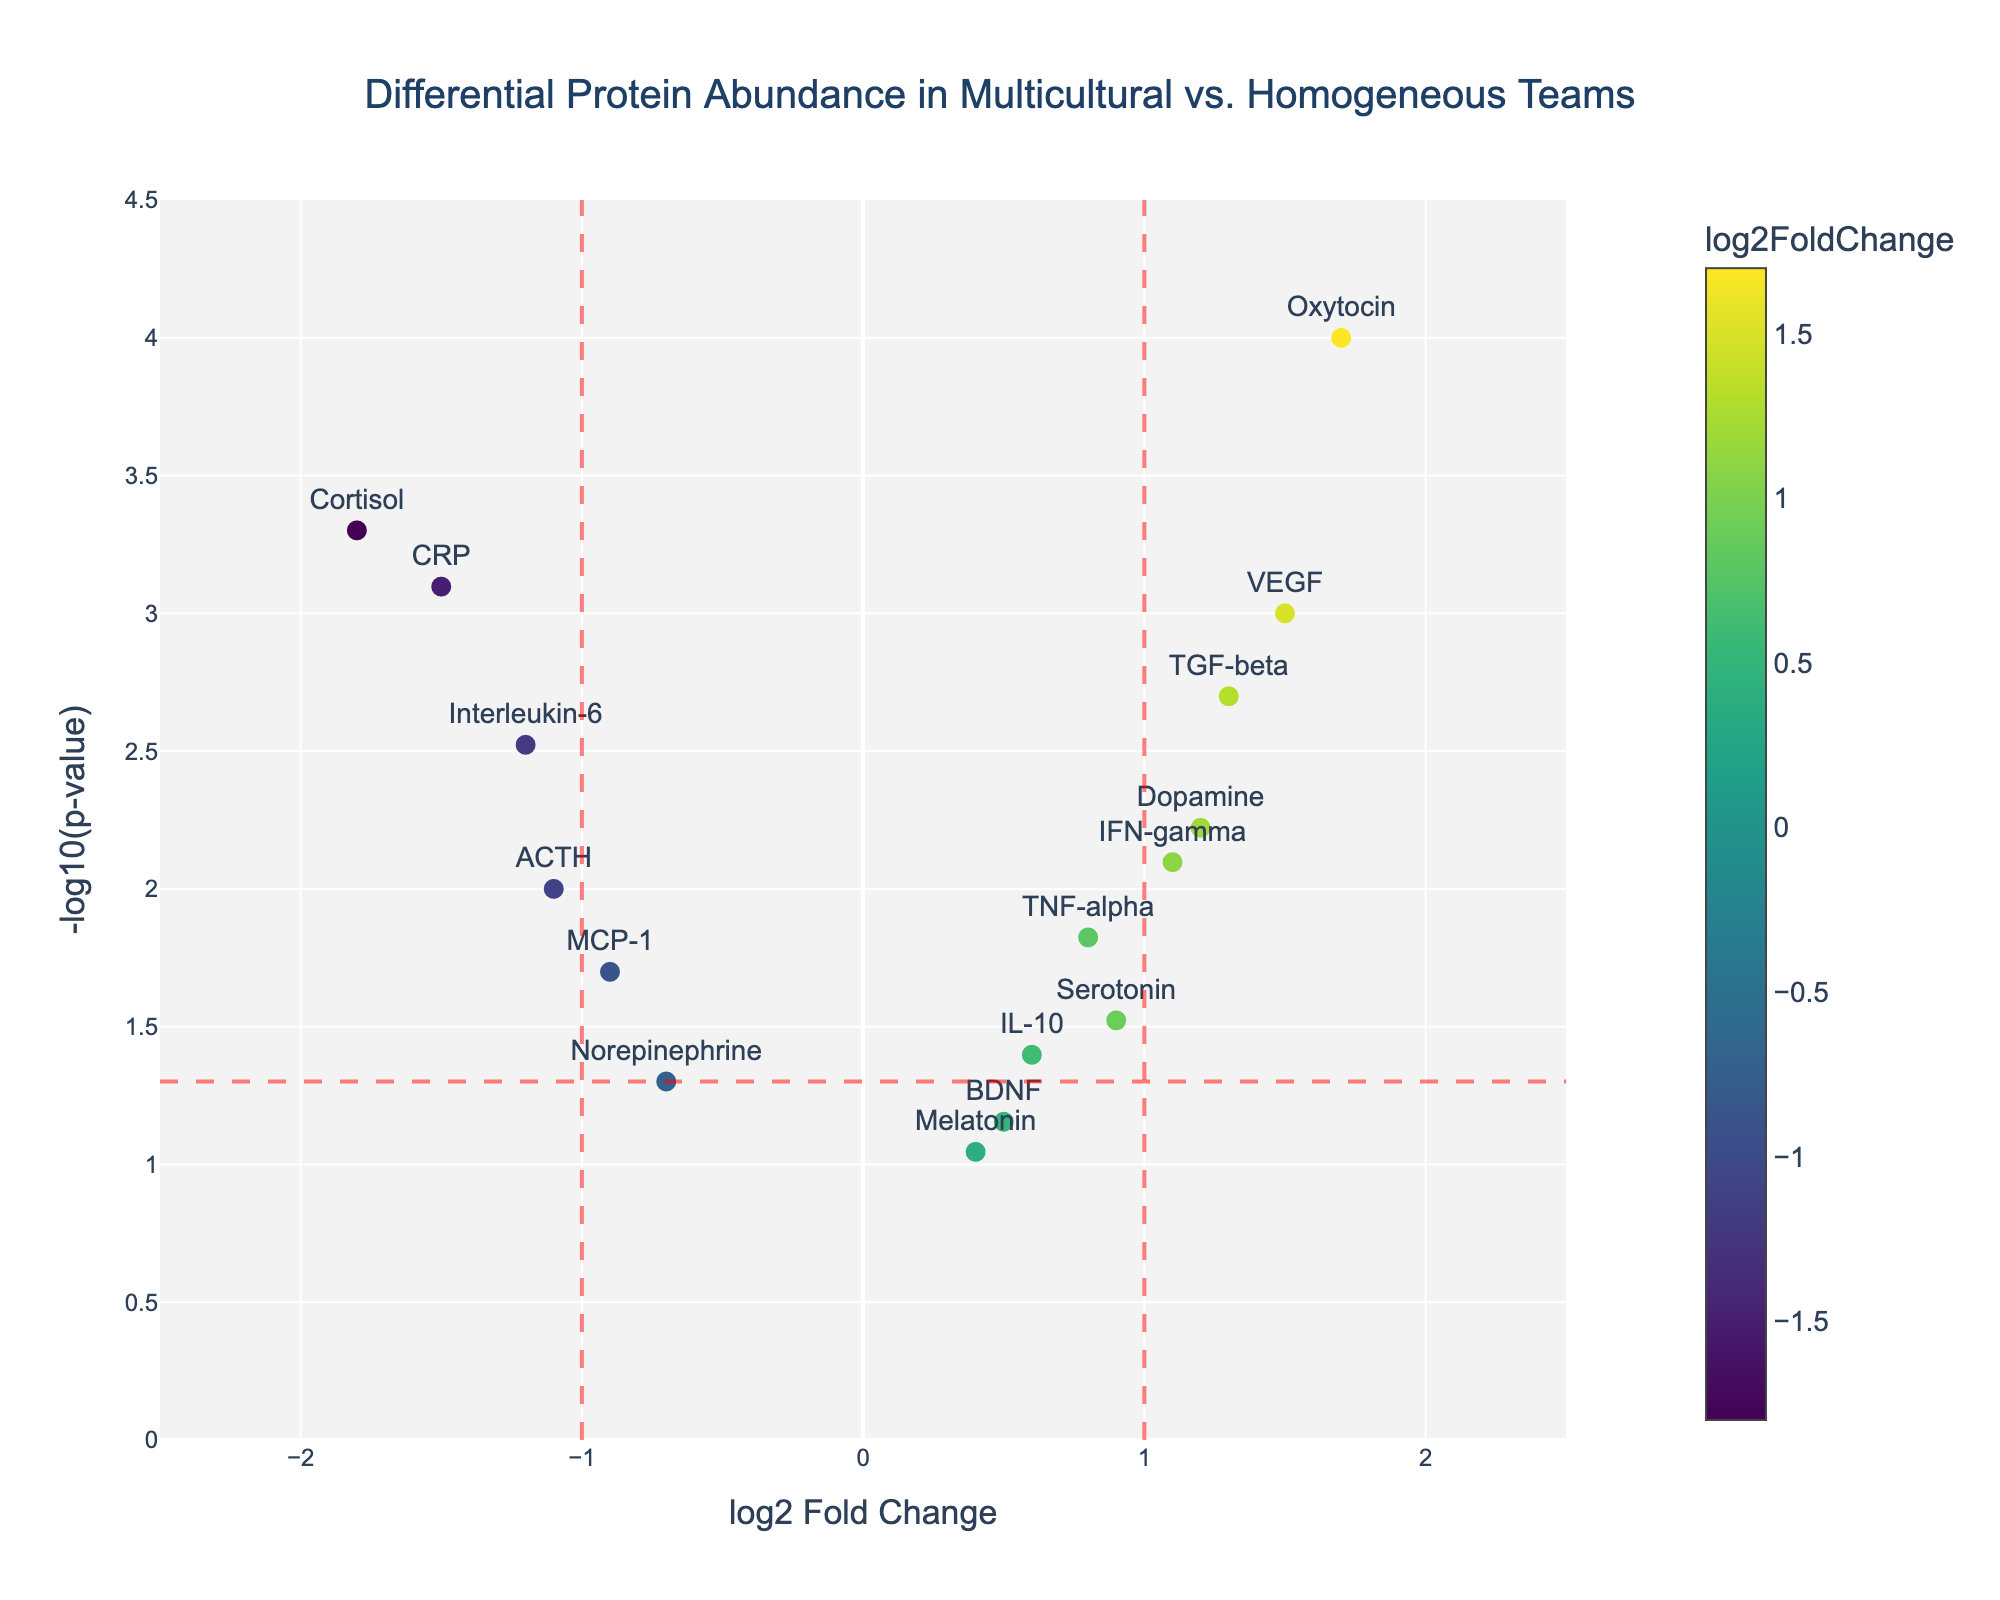What's the title of the figure? The title of the figure is usually placed at the top center of the plot.
Answer: Differential Protein Abundance in Multicultural vs. Homogeneous Teams What are the units for the x-axis? The units for the x-axis are mentioned as "log2 Fold Change". This indicates the logarithmic base 2 fold change in protein abundance.
Answer: log2 Fold Change How many proteins are significantly upregulated with a p-value < 0.05 and log2FoldChange > 1? To find this, look for points above the horizontal dashed red line (p-value < 0.05) and to the right of the vertical red line at log2FoldChange = 1.
Answer: 3 (VEGF, TGF-beta, Oxytocin) Which protein shows the highest log2FoldChange? To determine this, we look for the data point farthest to the right on the x-axis.
Answer: Oxytocin What does the color of the markers represent? The markers' color represents the log2FoldChange values, with a color scale shown on the plot.
Answer: log2FoldChange What protein has the lowest p-value? To identify this, find the point that is highest on the y-axis, since it represents the -log10(p-value).
Answer: Oxytocin Which protein is downregulated the most significantly? Look for the data point farthest to the left of the vertical line at log2FoldChange = -1 and also below the horizontal line at -log10(0.05).
Answer: Cortisol How many proteins have both a negative log2FoldChange and a p-value < 0.05? Count the points to the left of log2FoldChange = -1 and above the horizontal dashed line.
Answer: 3 (Interleukin-6, MCP-1, Cortisol, CRP) What log2FoldChange value is associated with TGF-beta, and what is its significance level? Identify TGF-beta on the plot, read its x-axis (log2FoldChange) and y-axis (-log10(p-value)) values. Then convert -log10(p-value) back to the p-value.
Answer: log2FoldChange: 1.3, p-value: 0.002 